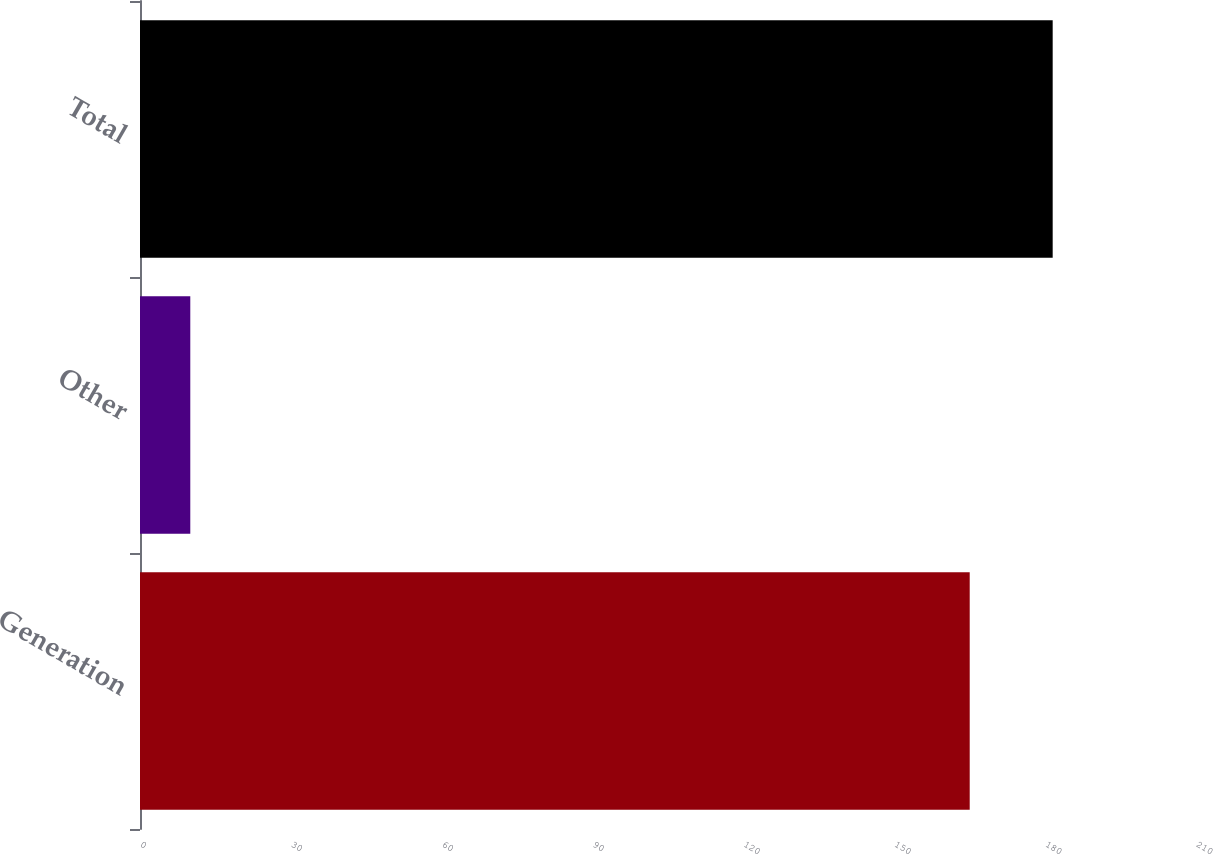<chart> <loc_0><loc_0><loc_500><loc_500><bar_chart><fcel>Generation<fcel>Other<fcel>Total<nl><fcel>165<fcel>10<fcel>181.5<nl></chart> 